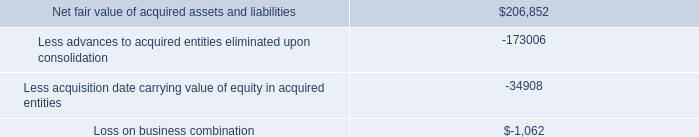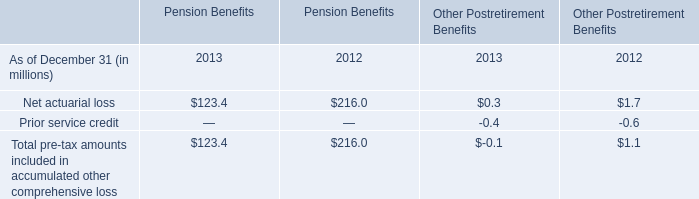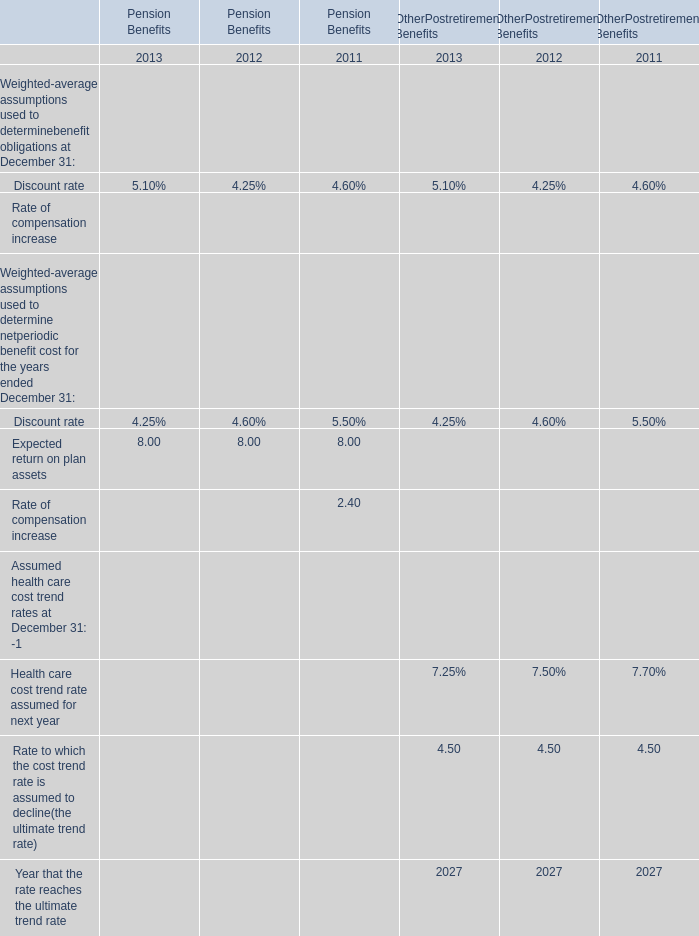For Other Postretirement Benefits,2013,when does the rate reach the ultimate trend rate? 
Answer: 2027. 